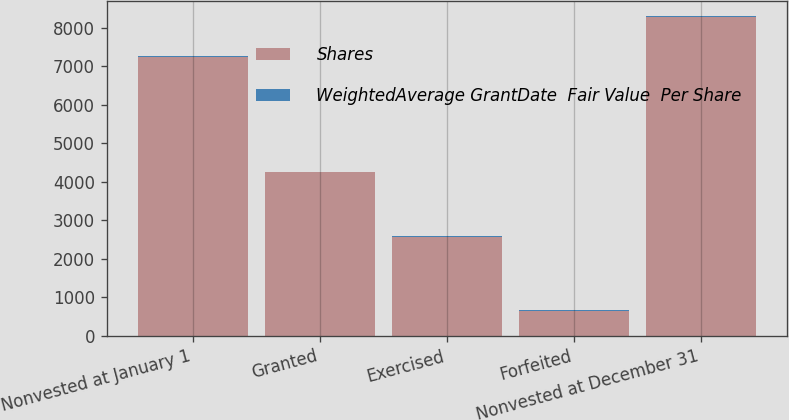Convert chart. <chart><loc_0><loc_0><loc_500><loc_500><stacked_bar_chart><ecel><fcel>Nonvested at January 1<fcel>Granted<fcel>Exercised<fcel>Forfeited<fcel>Nonvested at December 31<nl><fcel>Shares<fcel>7253<fcel>4250<fcel>2580<fcel>642<fcel>8281<nl><fcel>WeightedAverage GrantDate  Fair Value  Per Share<fcel>17.98<fcel>19.11<fcel>16.86<fcel>18.64<fcel>18.88<nl></chart> 